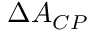Convert formula to latex. <formula><loc_0><loc_0><loc_500><loc_500>\Delta A _ { C P }</formula> 